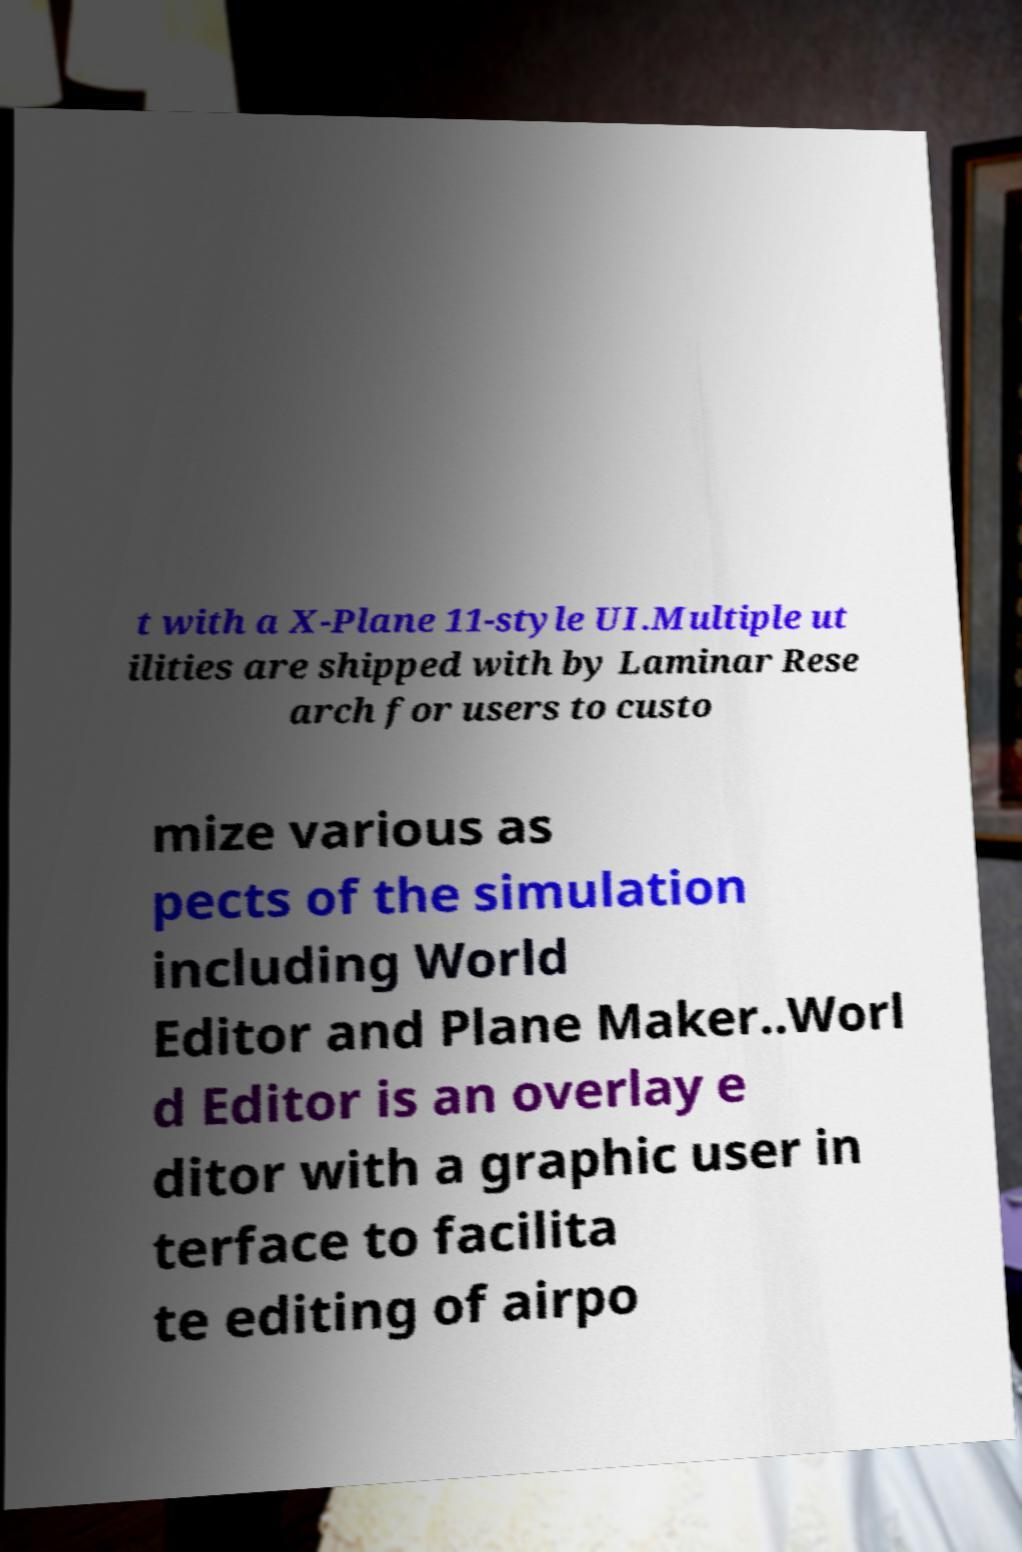Please read and relay the text visible in this image. What does it say? t with a X-Plane 11-style UI.Multiple ut ilities are shipped with by Laminar Rese arch for users to custo mize various as pects of the simulation including World Editor and Plane Maker..Worl d Editor is an overlay e ditor with a graphic user in terface to facilita te editing of airpo 